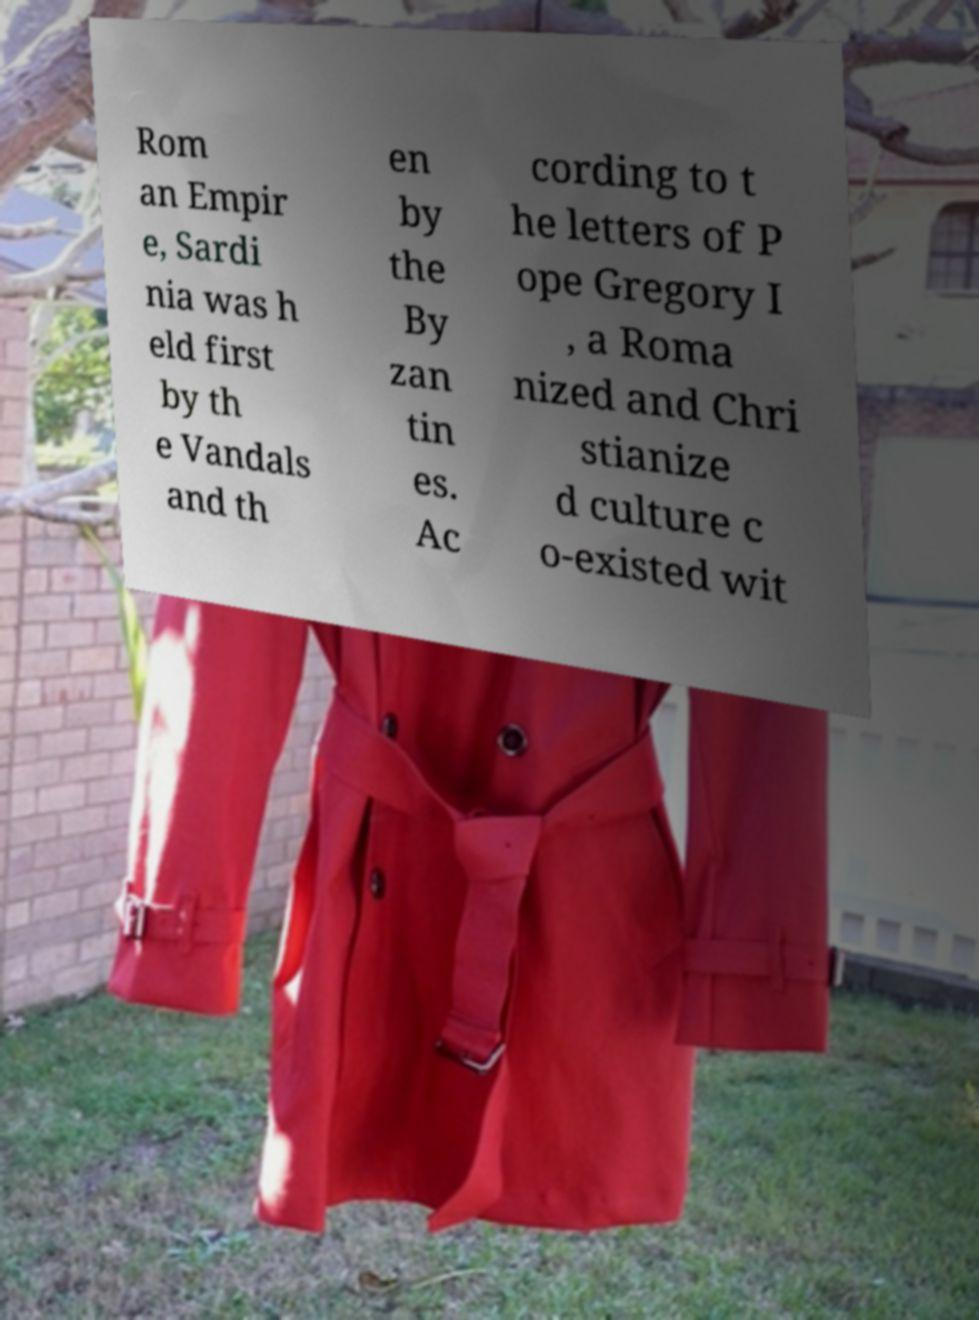What messages or text are displayed in this image? I need them in a readable, typed format. Rom an Empir e, Sardi nia was h eld first by th e Vandals and th en by the By zan tin es. Ac cording to t he letters of P ope Gregory I , a Roma nized and Chri stianize d culture c o-existed wit 